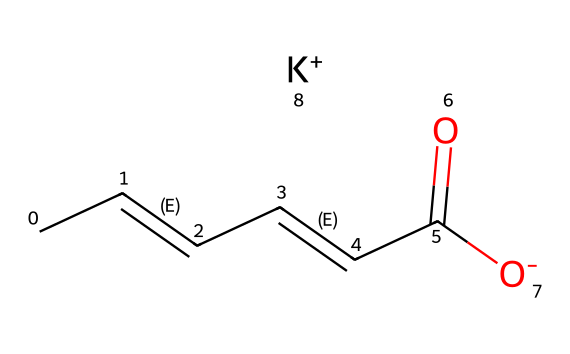What is the molecular formula of potassium sorbate? Potassium sorbate's structure shows that it is formed from carbon (C), hydrogen (H), oxygen (O), and potassium (K). The components can be counted to derive the molecular formula, which is C6H7O2K.
Answer: C6H7O2K How many carbon atoms are present in potassium sorbate? By examining the SMILES representation, we see six 'C' symbols, indicating the presence of six carbon atoms in the molecular structure.
Answer: 6 What type of bond connects the carbon atoms in the chain? The presence of '/C=C/' segments in the SMILES indicates that there are double bonds between some carbon atoms in the structure, representing unsaturation in the chain.
Answer: double bonds What ion accompanies the potassium sorbate molecule? The notation ‘[K+]’ in the SMILES representation clearly indicates that there is a potassium ion associated with the molecule, specifically a positively charged potassium ion.
Answer: potassium ion How many oxygen atoms are there in potassium sorbate? Analyzing the SMILES representation, there are two 'O' symbols present, signifying the presence of two oxygen atoms within the molecular structure.
Answer: 2 What functional group is present in potassium sorbate? The '-C(=O)[O-]' part of the SMILES indicates the presence of a carboxylate functional group, as it consists of a carbonyl (C=O) and a negatively charged hydroxyl (O-).
Answer: carboxylate What is the role of potassium sorbate in eco-friendly packaging? Potassium sorbate is known to act as a preservative, which helps prevent spoilage by inhibiting the growth of molds and yeasts, thus extending the shelf life of products in eco-friendly packaging.
Answer: preservative 